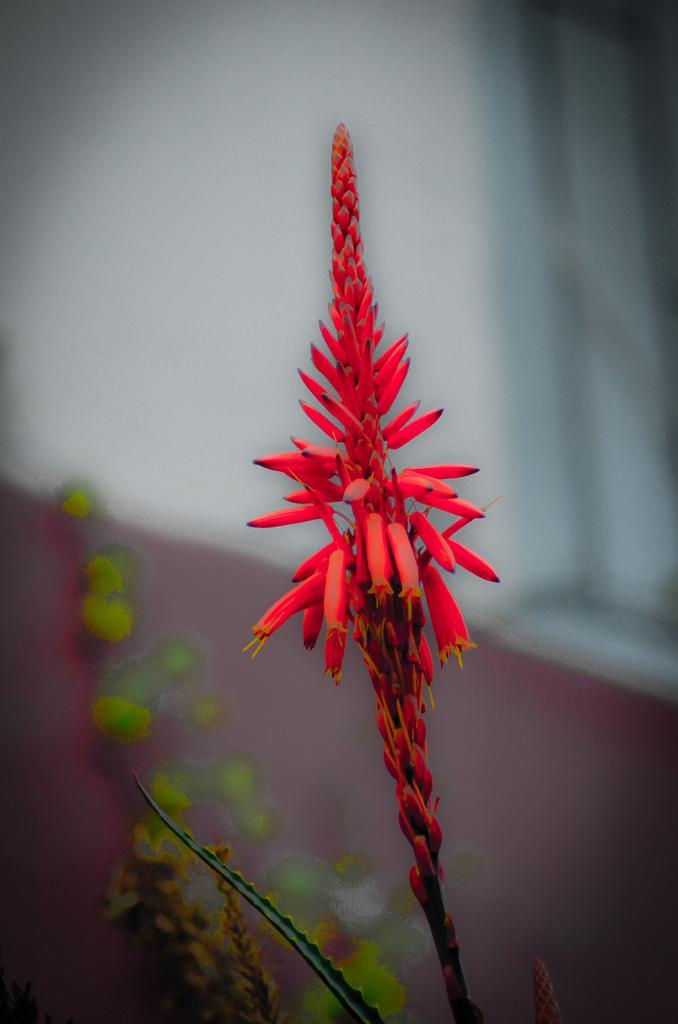Please provide a concise description of this image. In this picture we can see some flowers which are in red color and there are some leaves which are in green color. 